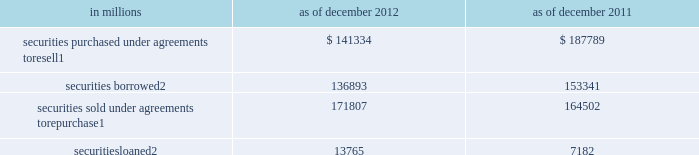Notes to consolidated financial statements note 9 .
Collateralized agreements and financings collateralized agreements are securities purchased under agreements to resell ( resale agreements or reverse repurchase agreements ) and securities borrowed .
Collateralized financings are securities sold under agreements to repurchase ( repurchase agreements ) , securities loaned and other secured financings .
The firm enters into these transactions in order to , among other things , facilitate client activities , invest excess cash , acquire securities to cover short positions and finance certain firm activities .
Collateralized agreements and financings are presented on a net-by-counterparty basis when a legal right of setoff exists .
Interest on collateralized agreements and collateralized financings is recognized over the life of the transaction and included in 201cinterest income 201d and 201cinterest expense , 201d respectively .
See note 23 for further information about interest income and interest expense .
The table below presents the carrying value of resale and repurchase agreements and securities borrowed and loaned transactions. .
In millions 2012 2011 securities purchased under agreements to resell 1 $ 141334 $ 187789 securities borrowed 2 136893 153341 securities sold under agreements to repurchase 1 171807 164502 securities loaned 2 13765 7182 1 .
Substantially all resale and repurchase agreements are carried at fair value under the fair value option .
See note 8 for further information about the valuation techniques and significant inputs used to determine fair value .
As of december 2012 and december 2011 , $ 38.40 billion and $ 47.62 billion of securities borrowed , and $ 1.56 billion and $ 107 million of securities loaned were at fair value , respectively .
Resale and repurchase agreements a resale agreement is a transaction in which the firm purchases financial instruments from a seller , typically in exchange for cash , and simultaneously enters into an agreement to resell the same or substantially the same financial instruments to the seller at a stated price plus accrued interest at a future date .
A repurchase agreement is a transaction in which the firm sells financial instruments to a buyer , typically in exchange for cash , and simultaneously enters into an agreement to repurchase the same or substantially the same financial instruments from the buyer at a stated price plus accrued interest at a future date .
The financial instruments purchased or sold in resale and repurchase agreements typically include u.s .
Government and federal agency , and investment-grade sovereign obligations .
The firm receives financial instruments purchased under resale agreements , makes delivery of financial instruments sold under repurchase agreements , monitors the market value of these financial instruments on a daily basis , and delivers or obtains additional collateral due to changes in the market value of the financial instruments , as appropriate .
For resale agreements , the firm typically requires delivery of collateral with a fair value approximately equal to the carrying value of the relevant assets in the consolidated statements of financial condition .
Even though repurchase and resale agreements involve the legal transfer of ownership of financial instruments , they are accounted for as financing arrangements because they require the financial instruments to be repurchased or resold at the maturity of the agreement .
However , 201crepos to maturity 201d are accounted for as sales .
A repo to maturity is a transaction in which the firm transfers a security under an agreement to repurchase the security where the maturity date of the repurchase agreement matches the maturity date of the underlying security .
Therefore , the firm effectively no longer has a repurchase obligation and has relinquished control over the underlying security and , accordingly , accounts for the transaction as a sale .
The firm had no repos to maturity outstanding as of december 2012 or december 2011 .
152 goldman sachs 2012 annual report .
What was the change in millions of securities sold under agreements to repurchase between 2011 and 2012? 
Computations: (171807 - 164502)
Answer: 7305.0. 